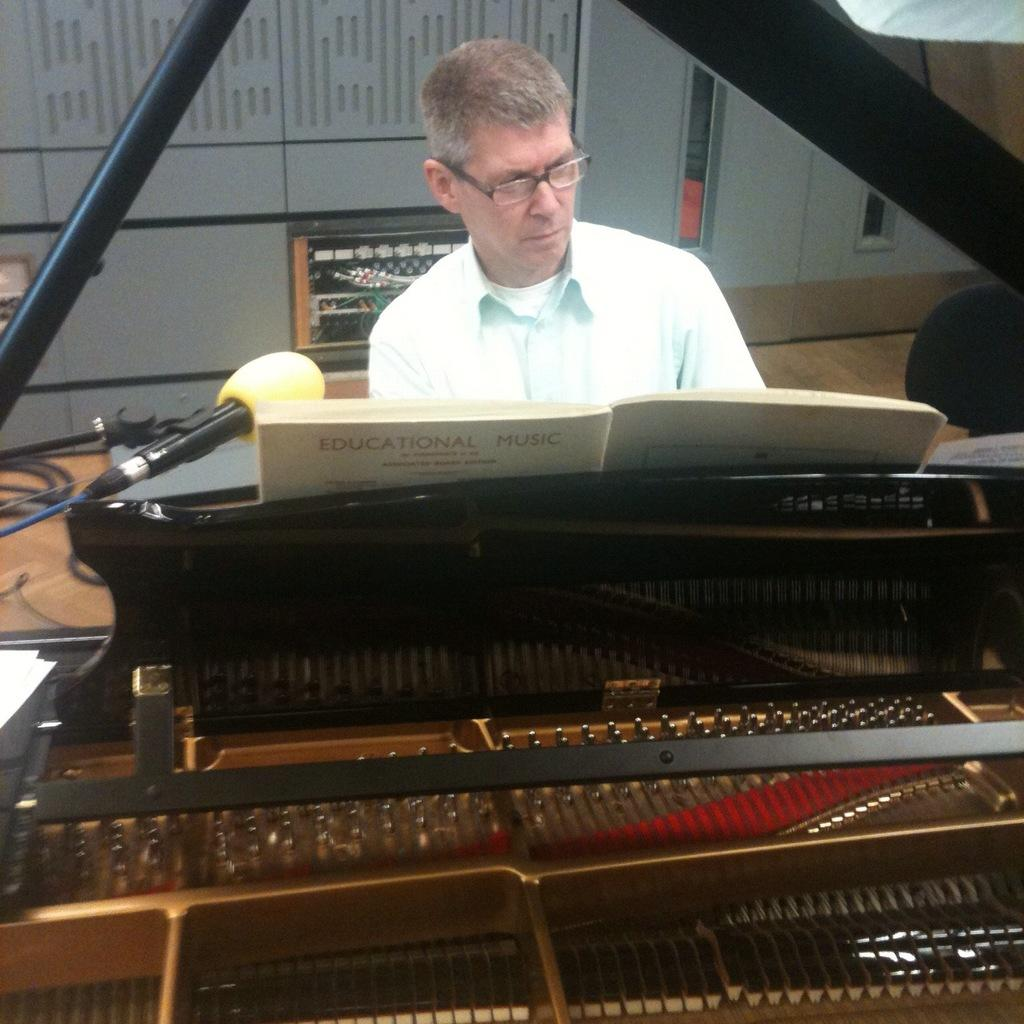Who is present in the image? There is a man in the image. What is the man doing in the image? The man is sitting in the image. What object is in front of the man? The man is in front of a piano. Are there any snails crawling on the piano in the image? There is no mention of snails or any other creatures in the image; it only features a man sitting in front of a piano. 